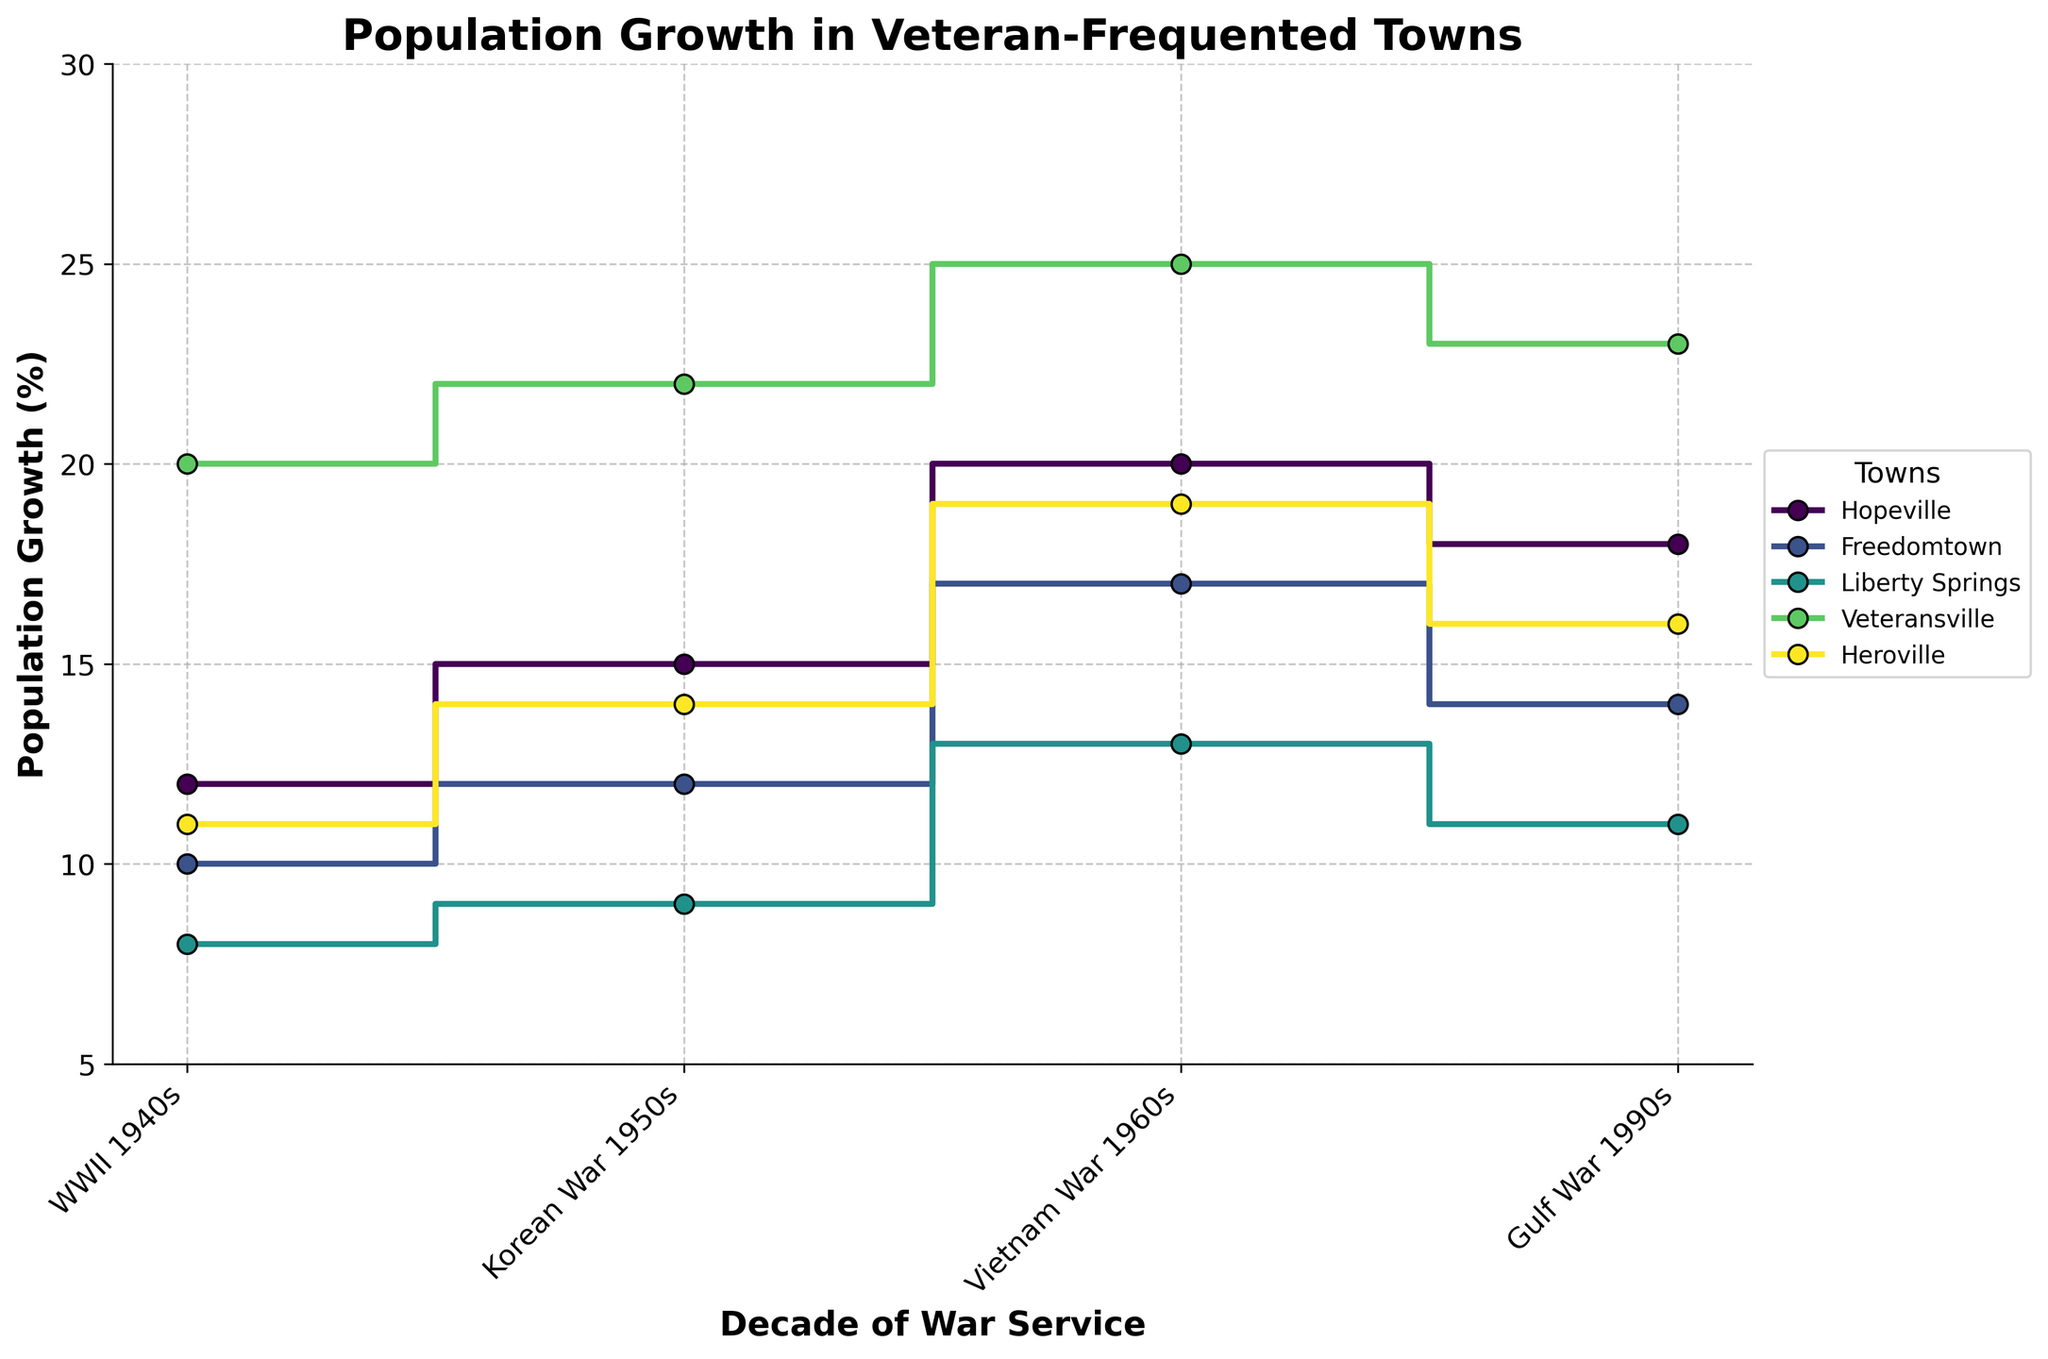What is the title of the figure? The title is located at the top of the figure and summarizes the content being displayed. The title is "Population Growth in Veteran-Frequented Towns".
Answer: Population Growth in Veteran-Frequented Towns What are the labels on the x-axis and y-axis? The labels for the axes give us an idea of what the figure is comparing. The x-axis is labeled "Decade of War Service" and the y-axis is labeled "Population Growth (%)".
Answer: Decade of War Service and Population Growth (%) How many towns are represented in the plot? There is a legend on the plot's side that lists all the towns being compared. There are five towns: Hopeville, Freedomtown, Liberty Springs, Veteransville, and Heroville.
Answer: Five towns Which town had the highest population growth in the Vietnam War 1960s? Find the line for each town and observe the point corresponding to the Vietnam War 1960s decade. Veteransville shows the highest growth with 25%.
Answer: Veteransville Which town had the lowest population growth in the WWII 1940s? Locate the WWII 1940s decade on the x-axis and observe each town's population growth. Liberty Springs had the lowest growth with 8%.
Answer: Liberty Springs What is the average population growth across all towns in the Gulf War 1990s? Identify the population growth values for each town in the Gulf War 1990s decade: Hopeville (18%), Freedomtown (14%), Liberty Springs (11%), Veteransville (23%), Heroville (16%). Average = (18 + 14 + 11 + 23 + 16) / 5 = 16.4%.
Answer: 16.4% What is the difference in population growth in WWII 1940s between Hopeville and Heroville? Identify the population growth for Hopeville (12%) and Heroville (11%) in WWII 1940s. Then, compute the difference: 12% - 11% = 1%.
Answer: 1% Did any town have a decrease in population growth from one decade to the next? Examine the steps of each town's population growth lines to see if any step goes downward. No town shows a downward step; all towns show either constant or increasing growth per decade.
Answer: No Which town shows a consistent increase in population growth across all decades? Examine each town's step line to see if it increases without any decreases or flat steps between decades. Veteransville shows a consistent increase.
Answer: Veteransville 